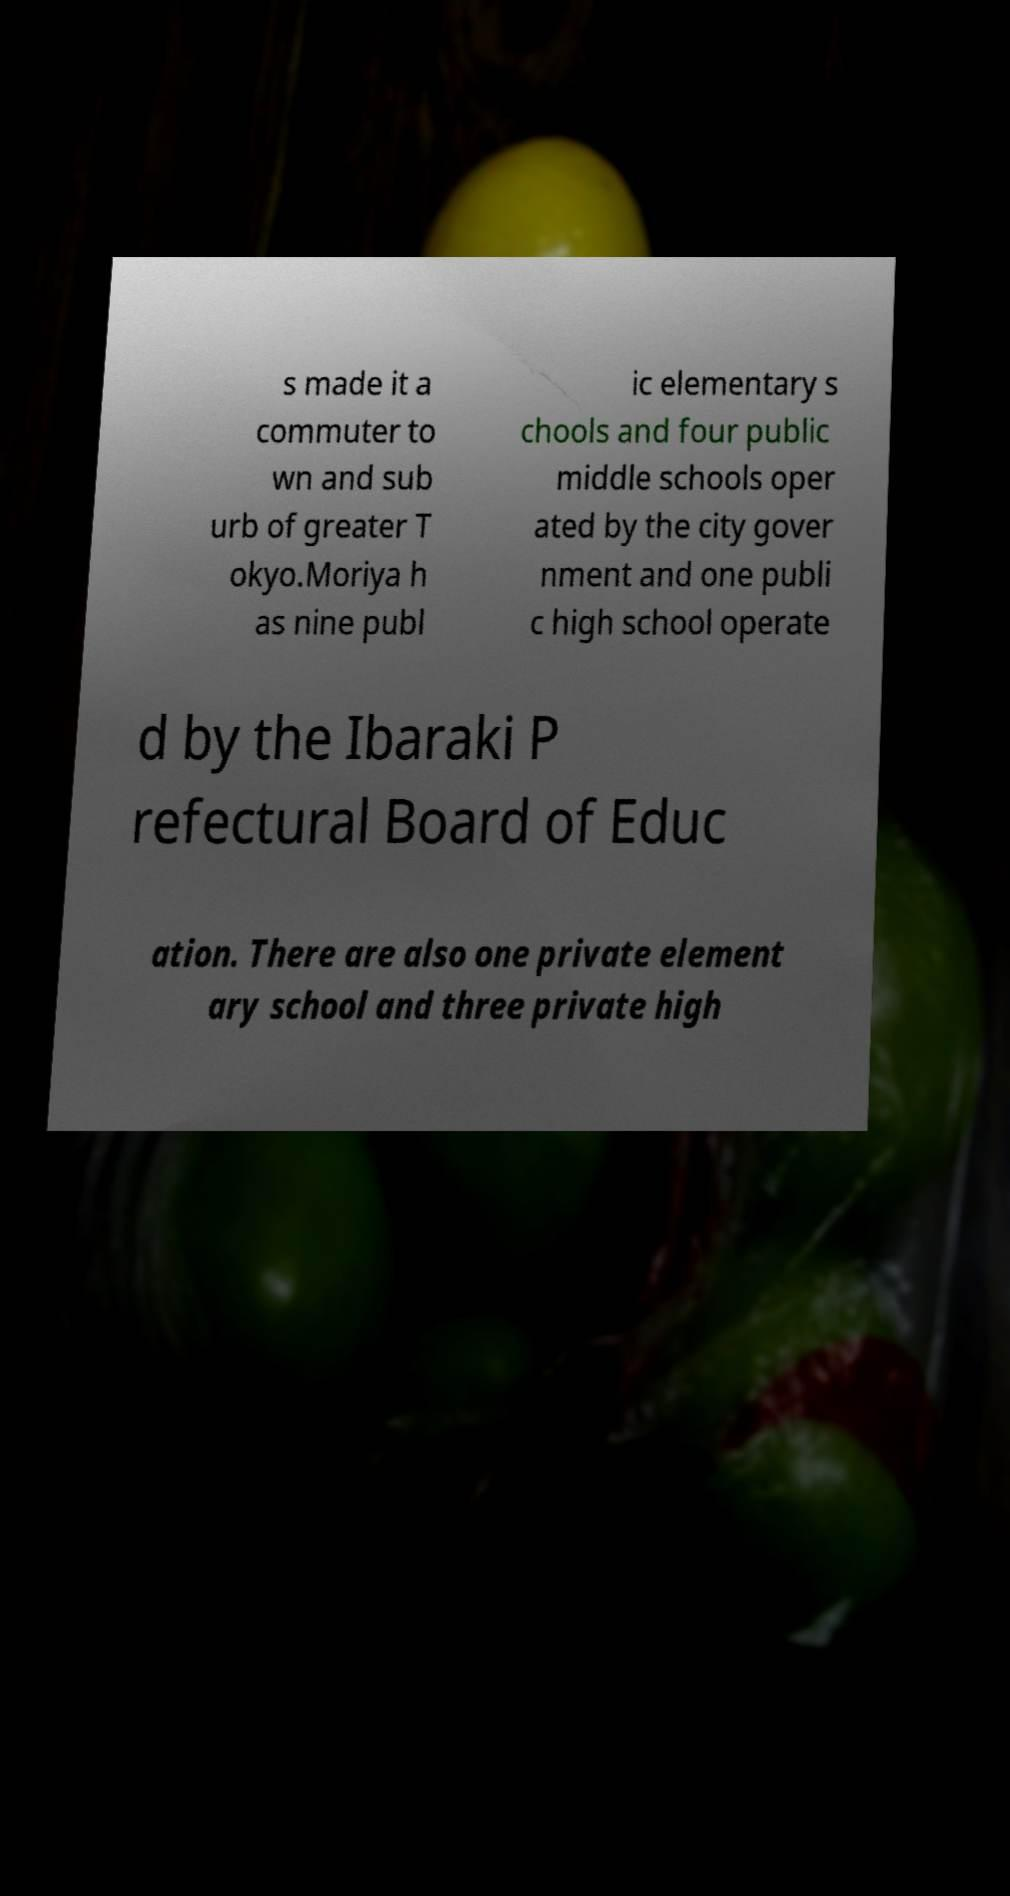I need the written content from this picture converted into text. Can you do that? s made it a commuter to wn and sub urb of greater T okyo.Moriya h as nine publ ic elementary s chools and four public middle schools oper ated by the city gover nment and one publi c high school operate d by the Ibaraki P refectural Board of Educ ation. There are also one private element ary school and three private high 